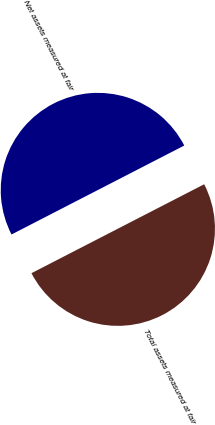<chart> <loc_0><loc_0><loc_500><loc_500><pie_chart><fcel>Total assets measured at fair<fcel>Net assets measured at fair<nl><fcel>50.0%<fcel>50.0%<nl></chart> 